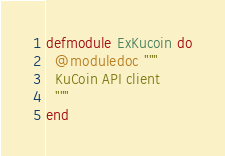<code> <loc_0><loc_0><loc_500><loc_500><_Elixir_>defmodule ExKucoin do
  @moduledoc """
  KuCoin API client
  """
end
</code> 